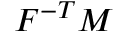<formula> <loc_0><loc_0><loc_500><loc_500>{ F } ^ { - T } { M }</formula> 